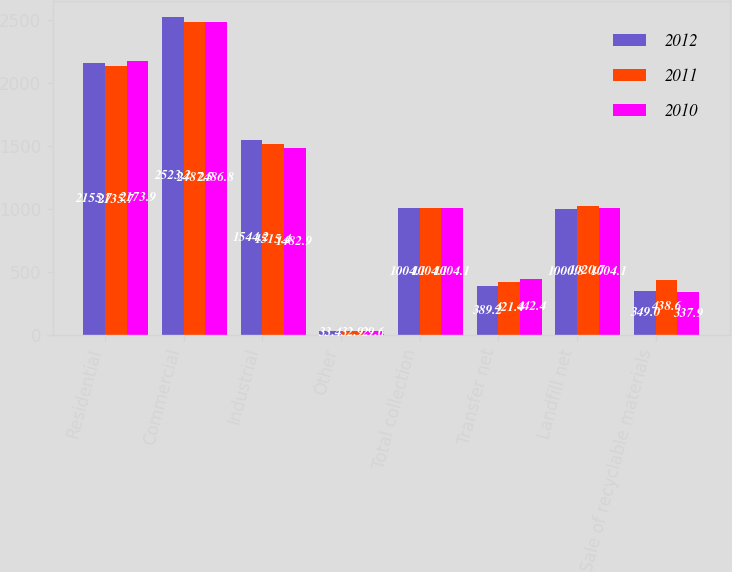<chart> <loc_0><loc_0><loc_500><loc_500><stacked_bar_chart><ecel><fcel>Residential<fcel>Commercial<fcel>Industrial<fcel>Other<fcel>Total collection<fcel>Transfer net<fcel>Landfill net<fcel>Sale of recyclable materials<nl><fcel>2012<fcel>2155.7<fcel>2523.2<fcel>1544.2<fcel>33.4<fcel>1004.1<fcel>389.2<fcel>1000.8<fcel>349<nl><fcel>2011<fcel>2135.7<fcel>2487.5<fcel>1515.4<fcel>32.9<fcel>1004.1<fcel>421.4<fcel>1020.7<fcel>438.6<nl><fcel>2010<fcel>2173.9<fcel>2486.8<fcel>1482.9<fcel>29.6<fcel>1004.1<fcel>442.4<fcel>1004.1<fcel>337.9<nl></chart> 